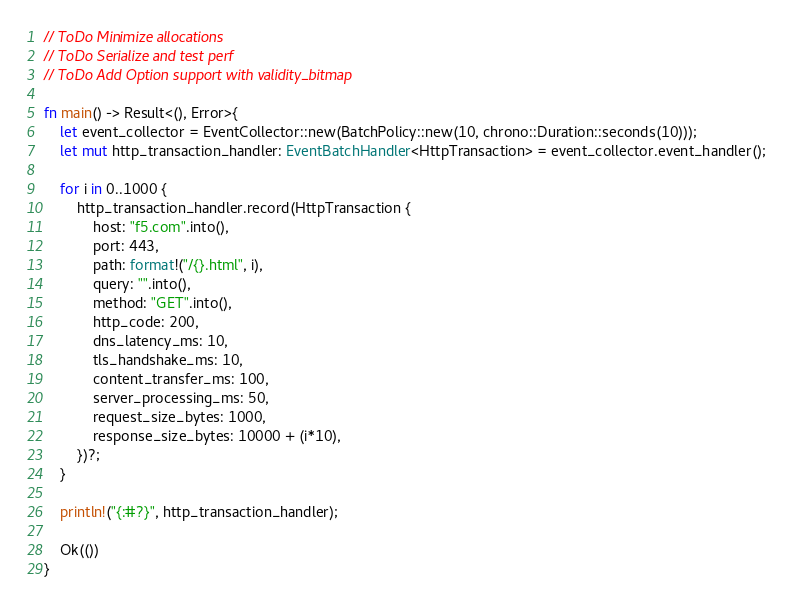<code> <loc_0><loc_0><loc_500><loc_500><_Rust_>
// ToDo Minimize allocations
// ToDo Serialize and test perf
// ToDo Add Option support with validity_bitmap

fn main() -> Result<(), Error>{
    let event_collector = EventCollector::new(BatchPolicy::new(10, chrono::Duration::seconds(10)));
    let mut http_transaction_handler: EventBatchHandler<HttpTransaction> = event_collector.event_handler();

    for i in 0..1000 {
        http_transaction_handler.record(HttpTransaction {
            host: "f5.com".into(),
            port: 443,
            path: format!("/{}.html", i),
            query: "".into(),
            method: "GET".into(),
            http_code: 200,
            dns_latency_ms: 10,
            tls_handshake_ms: 10,
            content_transfer_ms: 100,
            server_processing_ms: 50,
            request_size_bytes: 1000,
            response_size_bytes: 10000 + (i*10),
        })?;
    }

    println!("{:#?}", http_transaction_handler);

    Ok(())
}

</code> 